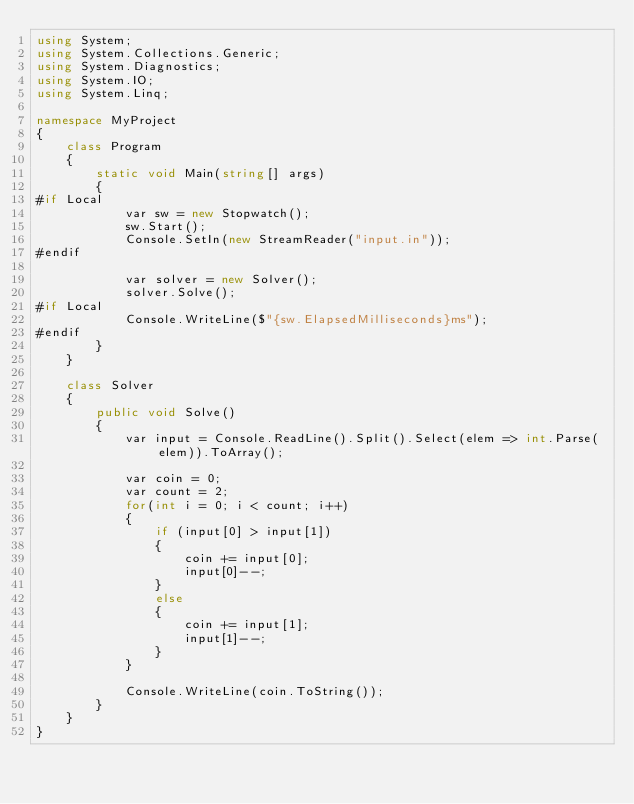Convert code to text. <code><loc_0><loc_0><loc_500><loc_500><_C#_>using System;
using System.Collections.Generic;
using System.Diagnostics;
using System.IO;
using System.Linq;

namespace MyProject
{
    class Program
    {
        static void Main(string[] args)
        {
#if Local
            var sw = new Stopwatch();
            sw.Start();
            Console.SetIn(new StreamReader("input.in"));
#endif

            var solver = new Solver();
            solver.Solve();
#if Local
            Console.WriteLine($"{sw.ElapsedMilliseconds}ms");
#endif
        }
    }

    class Solver
    {
        public void Solve()
        {
            var input = Console.ReadLine().Split().Select(elem => int.Parse(elem)).ToArray();

            var coin = 0;
            var count = 2;
            for(int i = 0; i < count; i++)
            {
                if (input[0] > input[1])
                {
                    coin += input[0];
                    input[0]--;
                }
                else
                {
                    coin += input[1];
                    input[1]--;
                }
            }
            
            Console.WriteLine(coin.ToString());
        }
    }
}
</code> 